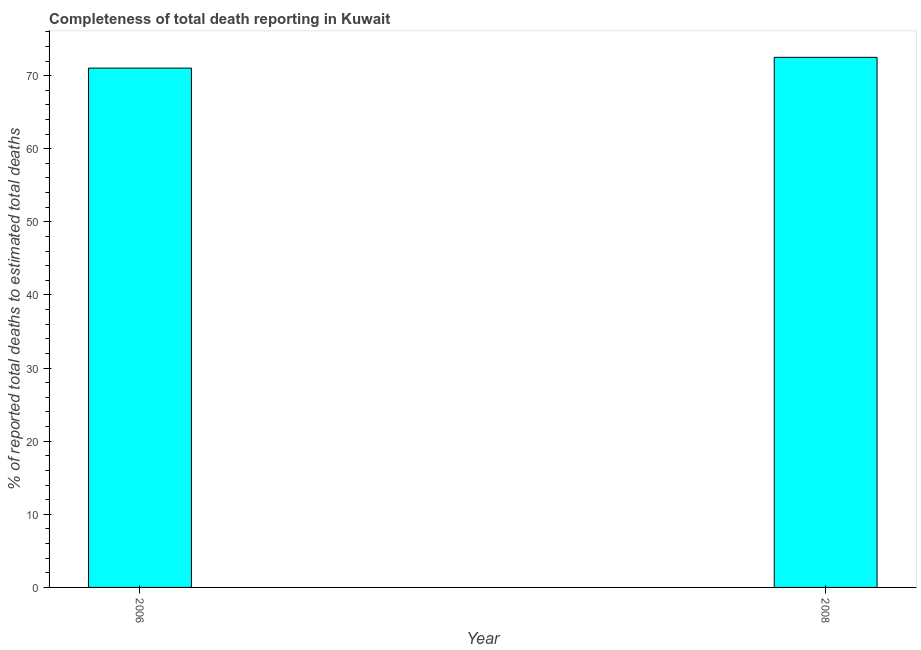What is the title of the graph?
Offer a terse response. Completeness of total death reporting in Kuwait. What is the label or title of the X-axis?
Make the answer very short. Year. What is the label or title of the Y-axis?
Make the answer very short. % of reported total deaths to estimated total deaths. What is the completeness of total death reports in 2006?
Ensure brevity in your answer.  71.03. Across all years, what is the maximum completeness of total death reports?
Make the answer very short. 72.5. Across all years, what is the minimum completeness of total death reports?
Offer a very short reply. 71.03. In which year was the completeness of total death reports maximum?
Provide a succinct answer. 2008. What is the sum of the completeness of total death reports?
Your answer should be compact. 143.53. What is the difference between the completeness of total death reports in 2006 and 2008?
Your answer should be very brief. -1.47. What is the average completeness of total death reports per year?
Keep it short and to the point. 71.77. What is the median completeness of total death reports?
Your answer should be compact. 71.77. Do a majority of the years between 2008 and 2006 (inclusive) have completeness of total death reports greater than 68 %?
Offer a very short reply. No. What is the ratio of the completeness of total death reports in 2006 to that in 2008?
Your response must be concise. 0.98. Is the completeness of total death reports in 2006 less than that in 2008?
Give a very brief answer. Yes. How many bars are there?
Your answer should be very brief. 2. How many years are there in the graph?
Make the answer very short. 2. What is the difference between two consecutive major ticks on the Y-axis?
Offer a very short reply. 10. What is the % of reported total deaths to estimated total deaths of 2006?
Your answer should be compact. 71.03. What is the % of reported total deaths to estimated total deaths in 2008?
Make the answer very short. 72.5. What is the difference between the % of reported total deaths to estimated total deaths in 2006 and 2008?
Give a very brief answer. -1.47. 